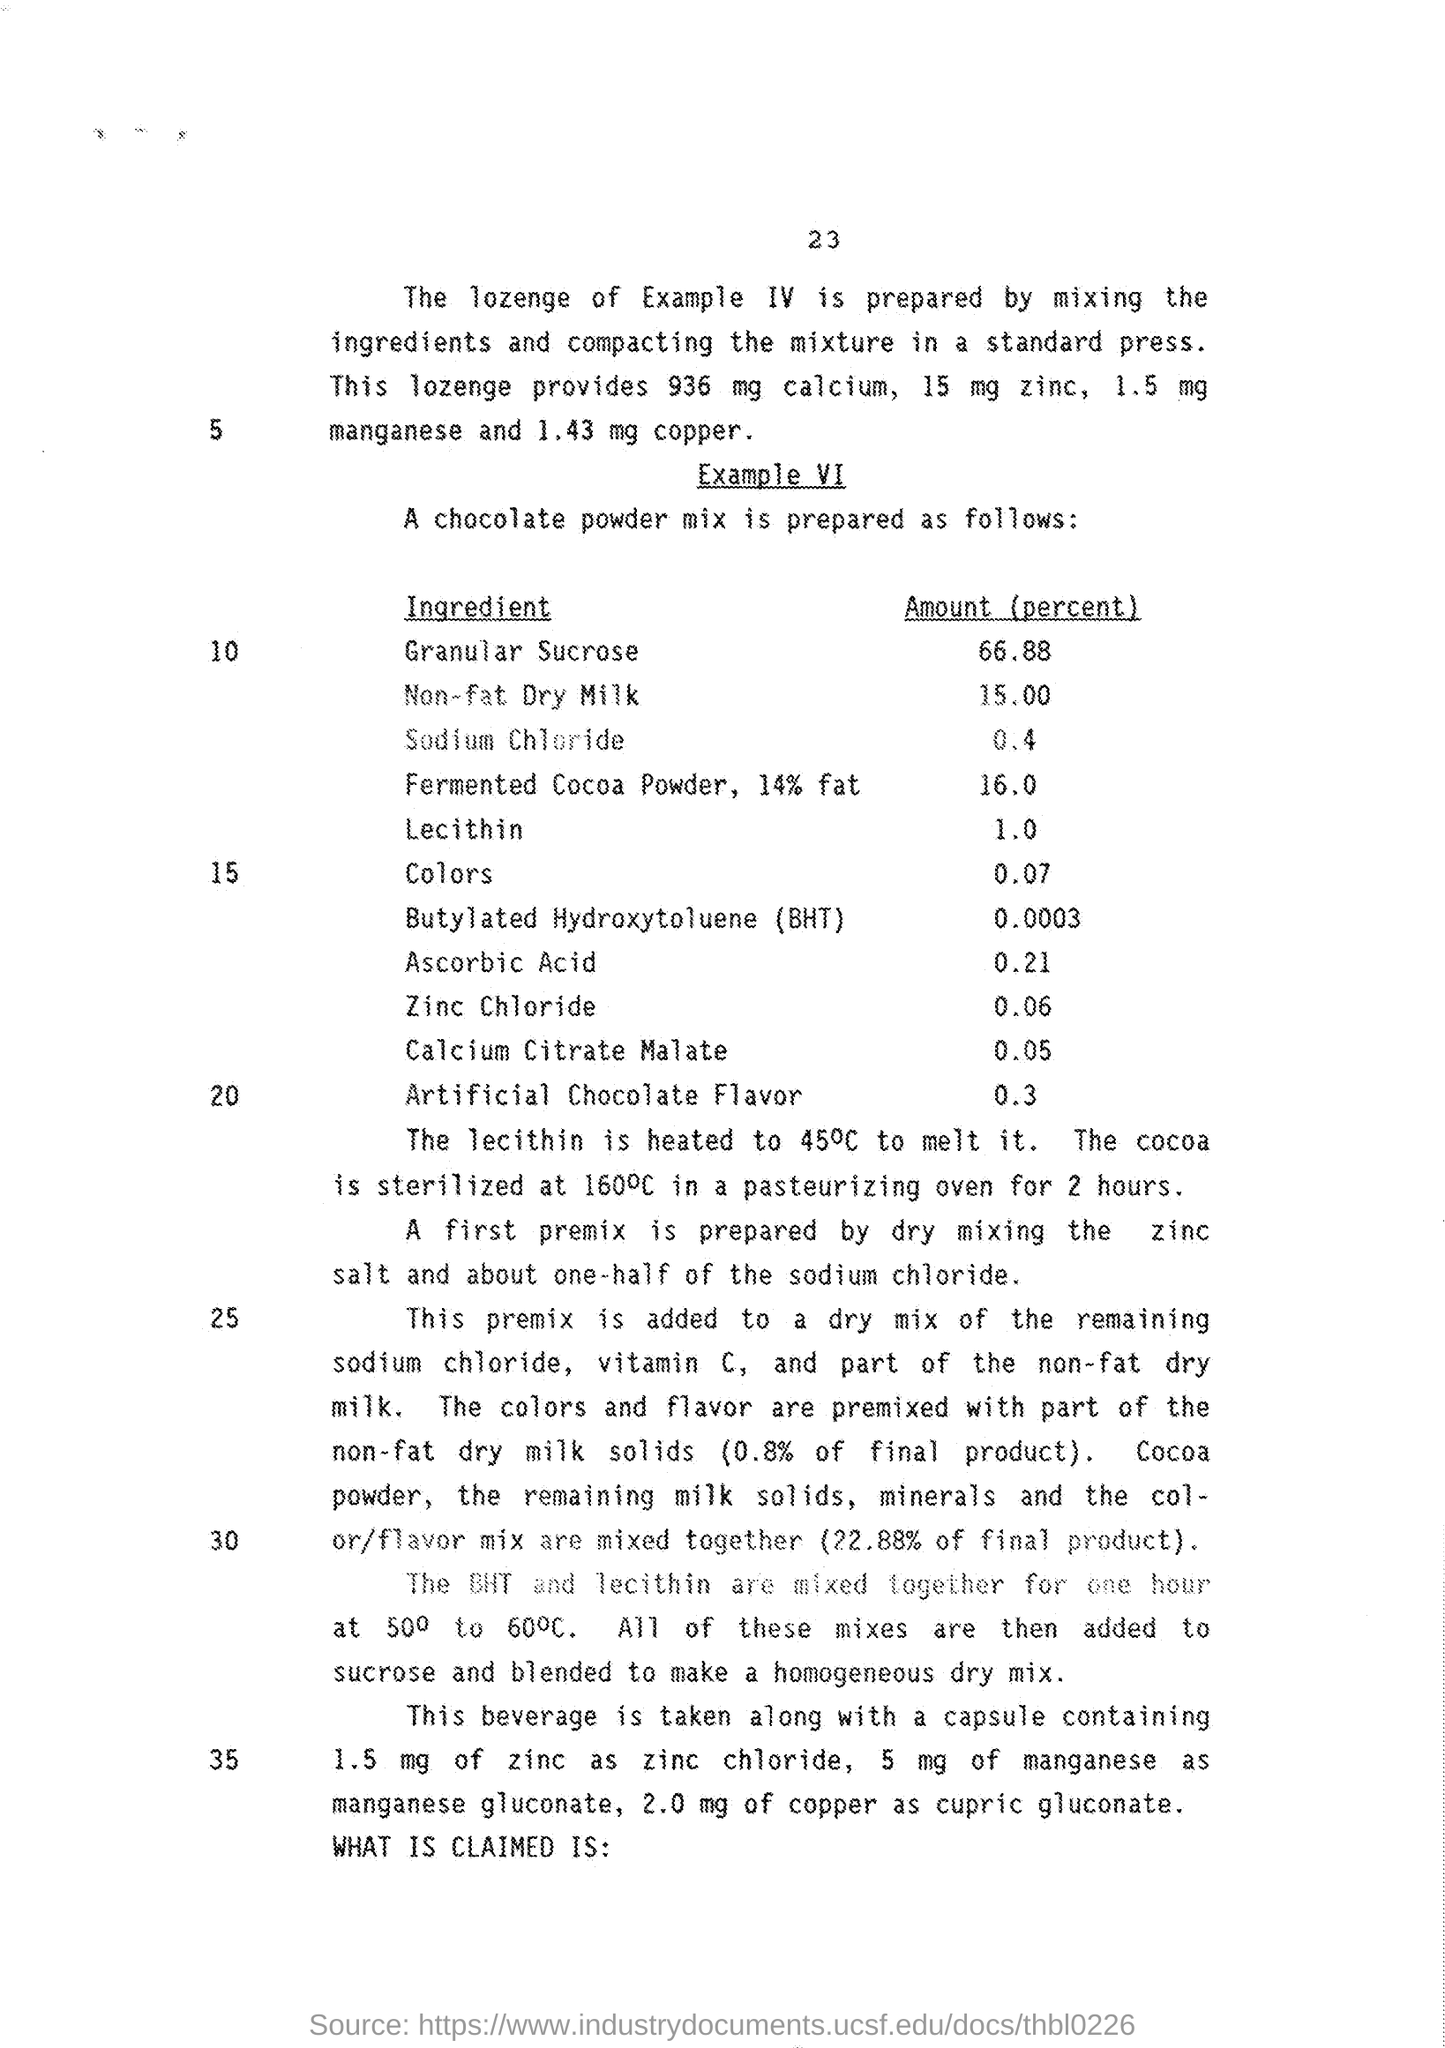Mention the quantity of "calcium" provided by lozenge?
Your answer should be compact. 936 mg. Mention the quantity of "zinc" provided by lozenge?
Make the answer very short. 15 mg. Mention the quantity of "manganese" provided by lozenge?
Your answer should be compact. 1.5 mg. Mention the quantity of "copper" provided by lozenge?
Your response must be concise. 1.43 mg. What is the Amount (percent) of "Granular Sucrose" provided?
Keep it short and to the point. 66.88. Mention the Amount (percent) of  ingredient "Lecithin"?
Provide a short and direct response. 1.0. What is the Amount (percent) of ingredient "Non-fat Dry Milk" provided?
Provide a short and direct response. 15.00. What is the Amount (percent) of ingredient "Ascorbic acid" provided?
Your answer should be very brief. 0.21. What is the Amount (percent) of ingredient "Zinc Chloride" provided?
Your response must be concise. 0.06. As mentioned in number "30" ,"The BHT and lecithin are mixed together for" what duration?
Make the answer very short. One hour. 